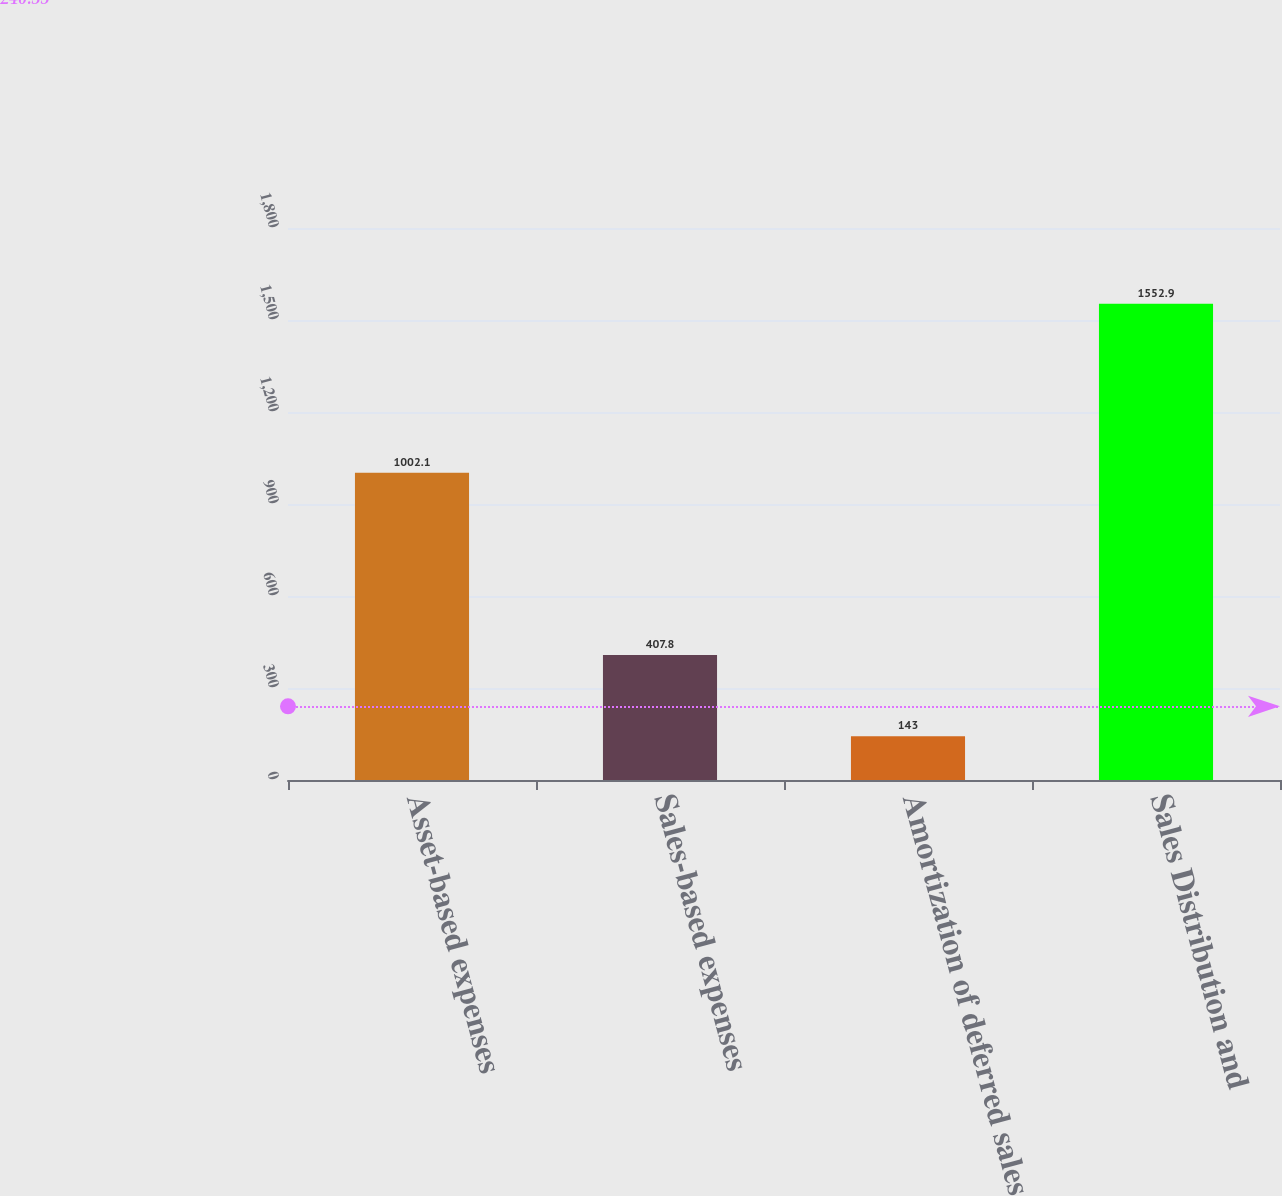Convert chart. <chart><loc_0><loc_0><loc_500><loc_500><bar_chart><fcel>Asset-based expenses<fcel>Sales-based expenses<fcel>Amortization of deferred sales<fcel>Sales Distribution and<nl><fcel>1002.1<fcel>407.8<fcel>143<fcel>1552.9<nl></chart> 